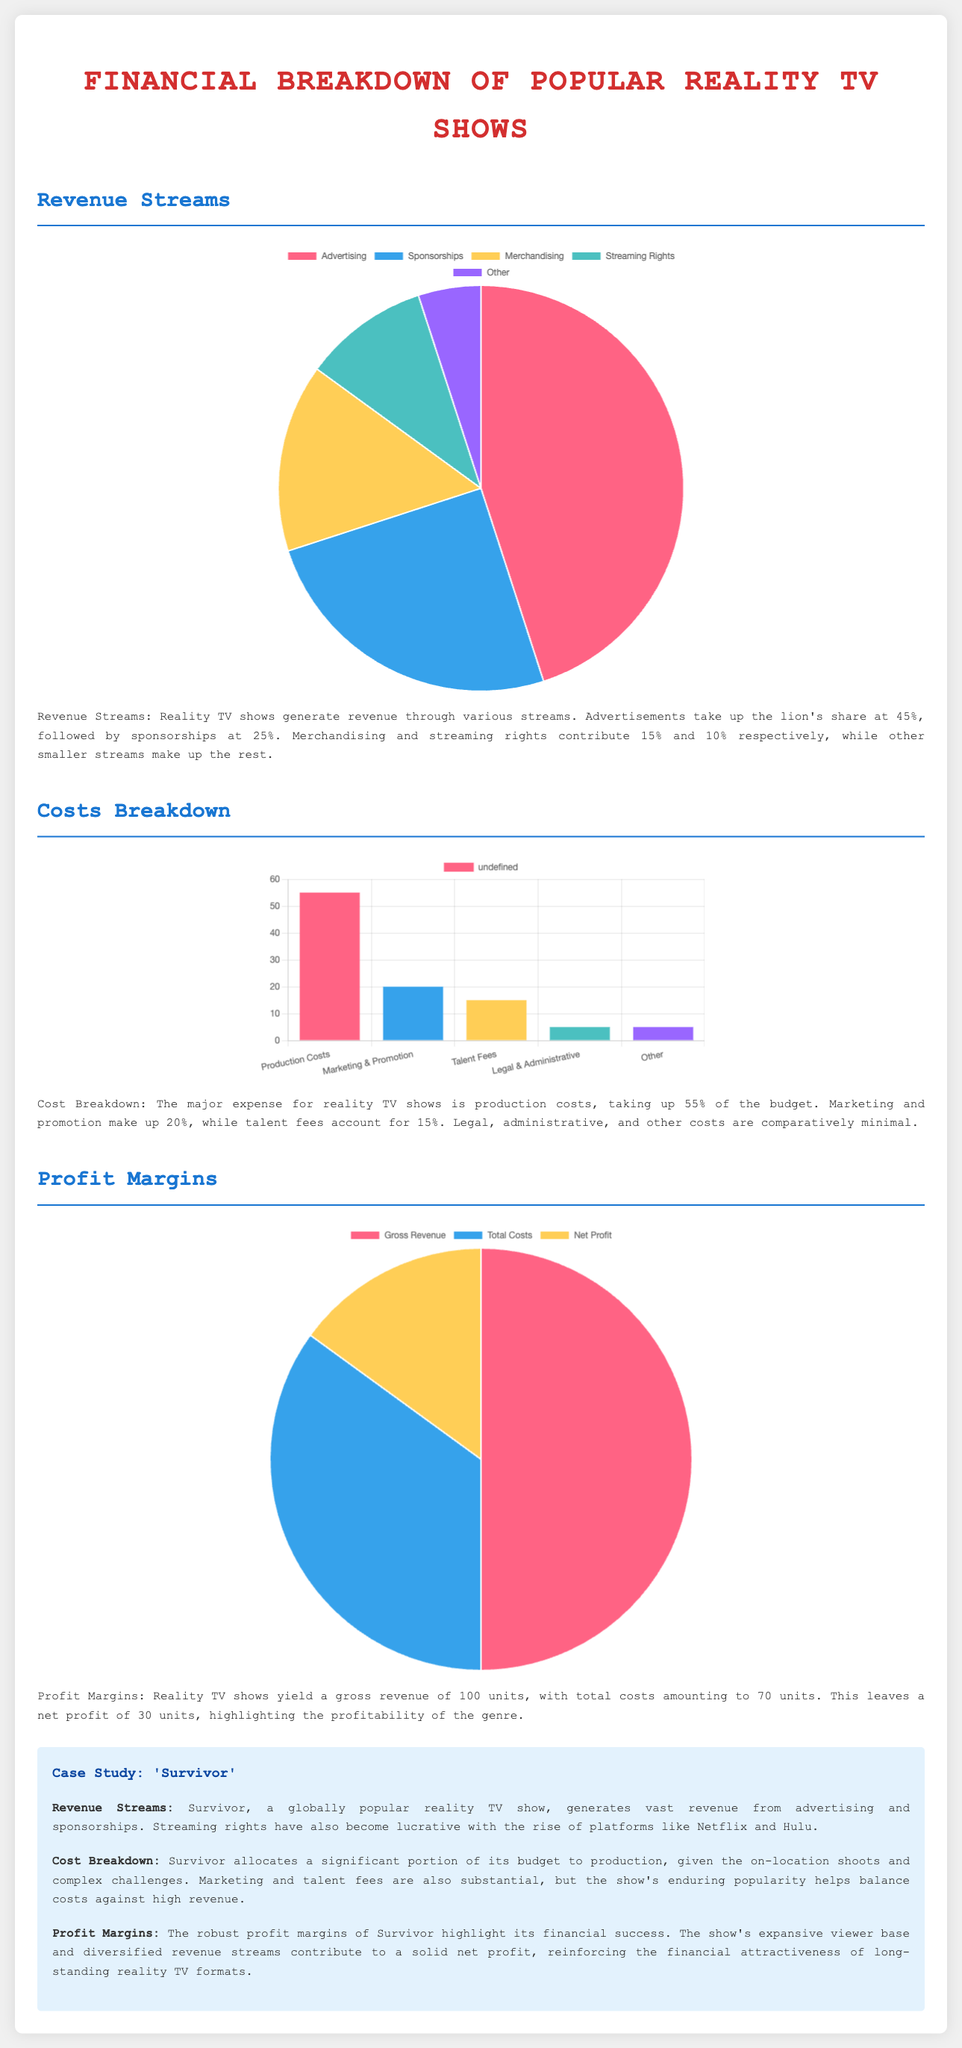What is the largest revenue source for reality TV shows? The largest revenue source is advertising, which constitutes 45% of total revenue.
Answer: Advertising What percentage of the budget is allocated to production costs? Production costs account for 55% of the total budget, making it the largest expense.
Answer: 55% What is the total cost for reality TV shows? Total costs amount to 70 units, as stated in the profit margins section.
Answer: 70 units How much net profit do reality TV shows make? The net profit is calculated as gross revenue minus total costs, resulting in 30 units.
Answer: 30 units Which revenue source contributes the least to the overall income? The revenue source contributing the least is "Other," which makes up 5% of total revenue.
Answer: Other How much of the costs is spent on legal and administrative fees? Legal and administrative costs account for only 5% of the overall costs.
Answer: 5% What type of chart is used for the profit margins? A pie chart is used to represent the profit margins visually in the infographic.
Answer: Pie chart What color represents merchandising in the revenue chart? In the revenue chart, merchandising is represented by the color yellow.
Answer: Yellow What is the main focus of the case study provided in the document? The case study focuses on "Survivor" and its financial aspects, including revenue and cost breakdown.
Answer: Survivor 